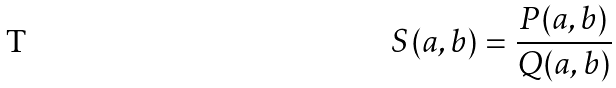<formula> <loc_0><loc_0><loc_500><loc_500>S ( a , b ) = \frac { P ( a , b ) } { Q ( a , b ) }</formula> 